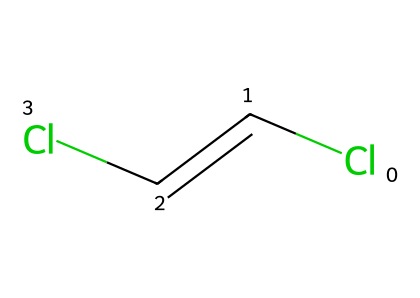What is the molecular formula of this compound? By analyzing the SMILES representation, ClC=CCl indicates two chlorine atoms (Cl) and four carbon and hydrogen atoms (C2H2). Thus, the molecular formula can be derived as C2H2Cl2.
Answer: C2H2Cl2 How many double bonds does this structure have? Observing the SMILES representation, we see the presence of the segment C=C, which indicates one double bond in the structure.
Answer: 1 What type of isomerism does this compound exhibit? The presence of two identical substituents (chlorine atoms) on opposite sides of the double bond (C=C) indicates that this compound exhibits cis-trans isomerism.
Answer: cis-trans isomerism How many geometric isomers can this compound have? Given the presence of one double bond and two equivalent halogen substituents, this compound can produce two geometric isomers: one cis and one trans version.
Answer: 2 What type of pollutant is represented by this compound? The chemical structure indicates that this compound is likely a type of chlorinated hydrocarbon, which are known environmental pollutants.
Answer: chlorinated hydrocarbon Which geometric isomer is represented by the provided structure: cis or trans? Analyzing the placement of the chlorine atoms, which are opposite each other, indicates that this compound is in its trans configuration.
Answer: trans 